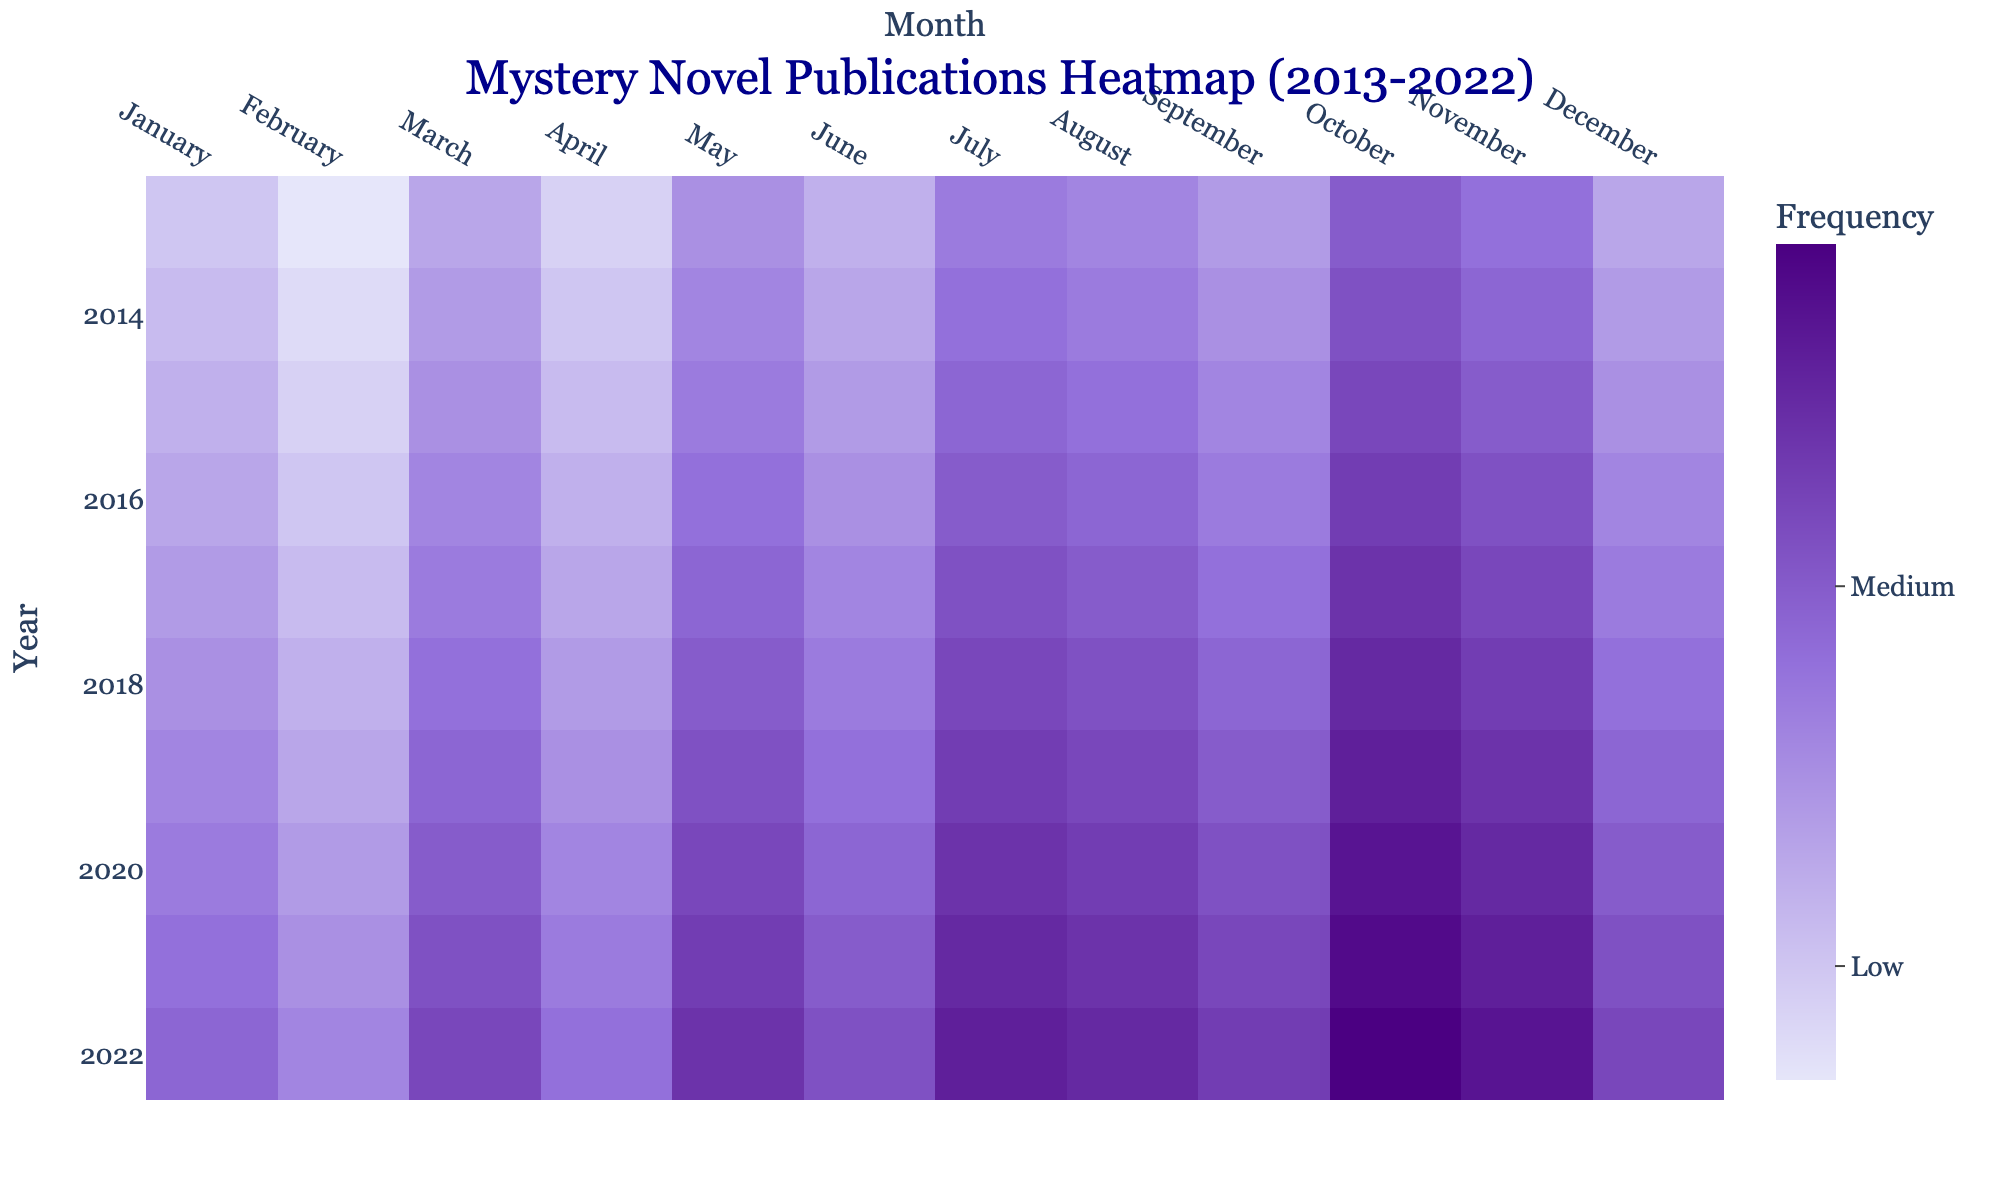How many publications were made in October 2017? The heatmap shows the frequency of publications for each month across different years. Locate the cell for October in the row for 2017.
Answer: 29 Which month in 2021 had the highest number of publications? To answer this, look at the row corresponding to the year 2021 and find the cell with the highest frequency value.
Answer: October What is the average number of publications for the month of April over the decade? Sum the frequencies for April from each year (14 + 15 + 16 + 17 + 18 + 19 + 20 + 21 + 22 + 23 = 185) and divide by 10 (the number of years).
Answer: 18.5 Is the number of publications consistently increasing, decreasing, or stable over the years? Check the values across the years for any consistent pattern. All months show an increasing trend in publication frequencies across the years.
Answer: Increasing Which year had the lowest number of publications for December? Look at the December column and identify the smallest value, then note the corresponding year.
Answer: 2013 Between which months is the difference in publication numbers most pronounced in 2020? Compare the values for each pair of months in 2020 (22 for January to 32 for October). The maximum difference is between January (22) and October (32).
Answer: January and October How many total publications were there in 2016? Sum all the values across the year 2016 (18 + 15 + 21 + 17 + 23 + 20 + 25 + 24 + 22 + 28 + 26 + 21 = 260).
Answer: 260 In which months did 2019 have fewer publications compared to 2021? Compare each month's value between 2019 and 2021 (January: 21 < 23, February: 18 < 20, etc.). The months are January through December, except none.
Answer: None Which month generally has the highest number of publications across all the years? Identify the column with the dark hues most frequently. October seems to be the darkest in most years.
Answer: October Are there any months where the frequency of publications never drops below 20, and if so, which? Check each month's column for frequencies never falling below 20. October, November, and December never drop below 20.
Answer: October, November, December 